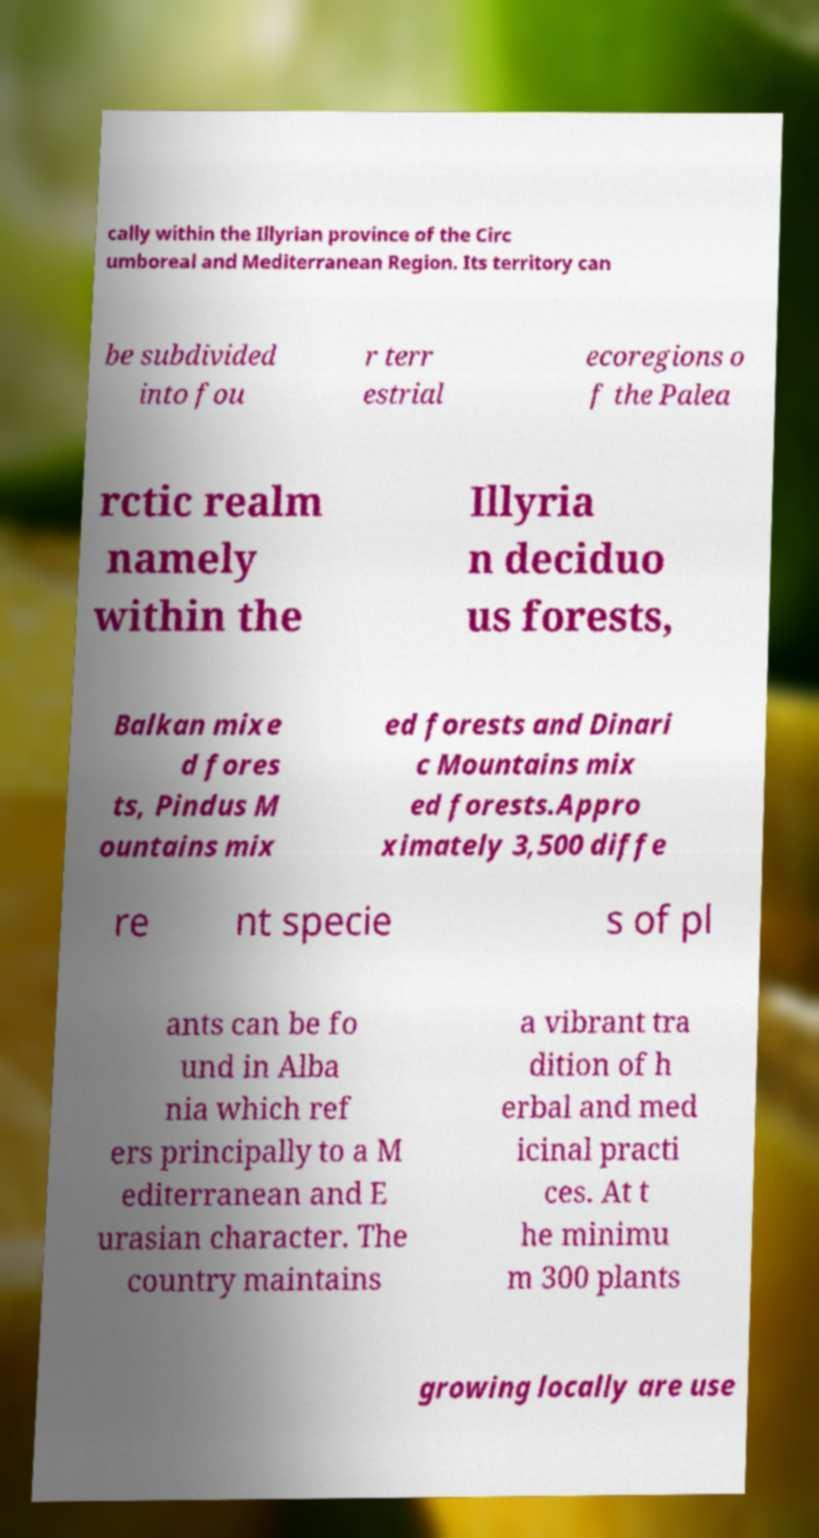What messages or text are displayed in this image? I need them in a readable, typed format. cally within the Illyrian province of the Circ umboreal and Mediterranean Region. Its territory can be subdivided into fou r terr estrial ecoregions o f the Palea rctic realm namely within the Illyria n deciduo us forests, Balkan mixe d fores ts, Pindus M ountains mix ed forests and Dinari c Mountains mix ed forests.Appro ximately 3,500 diffe re nt specie s of pl ants can be fo und in Alba nia which ref ers principally to a M editerranean and E urasian character. The country maintains a vibrant tra dition of h erbal and med icinal practi ces. At t he minimu m 300 plants growing locally are use 